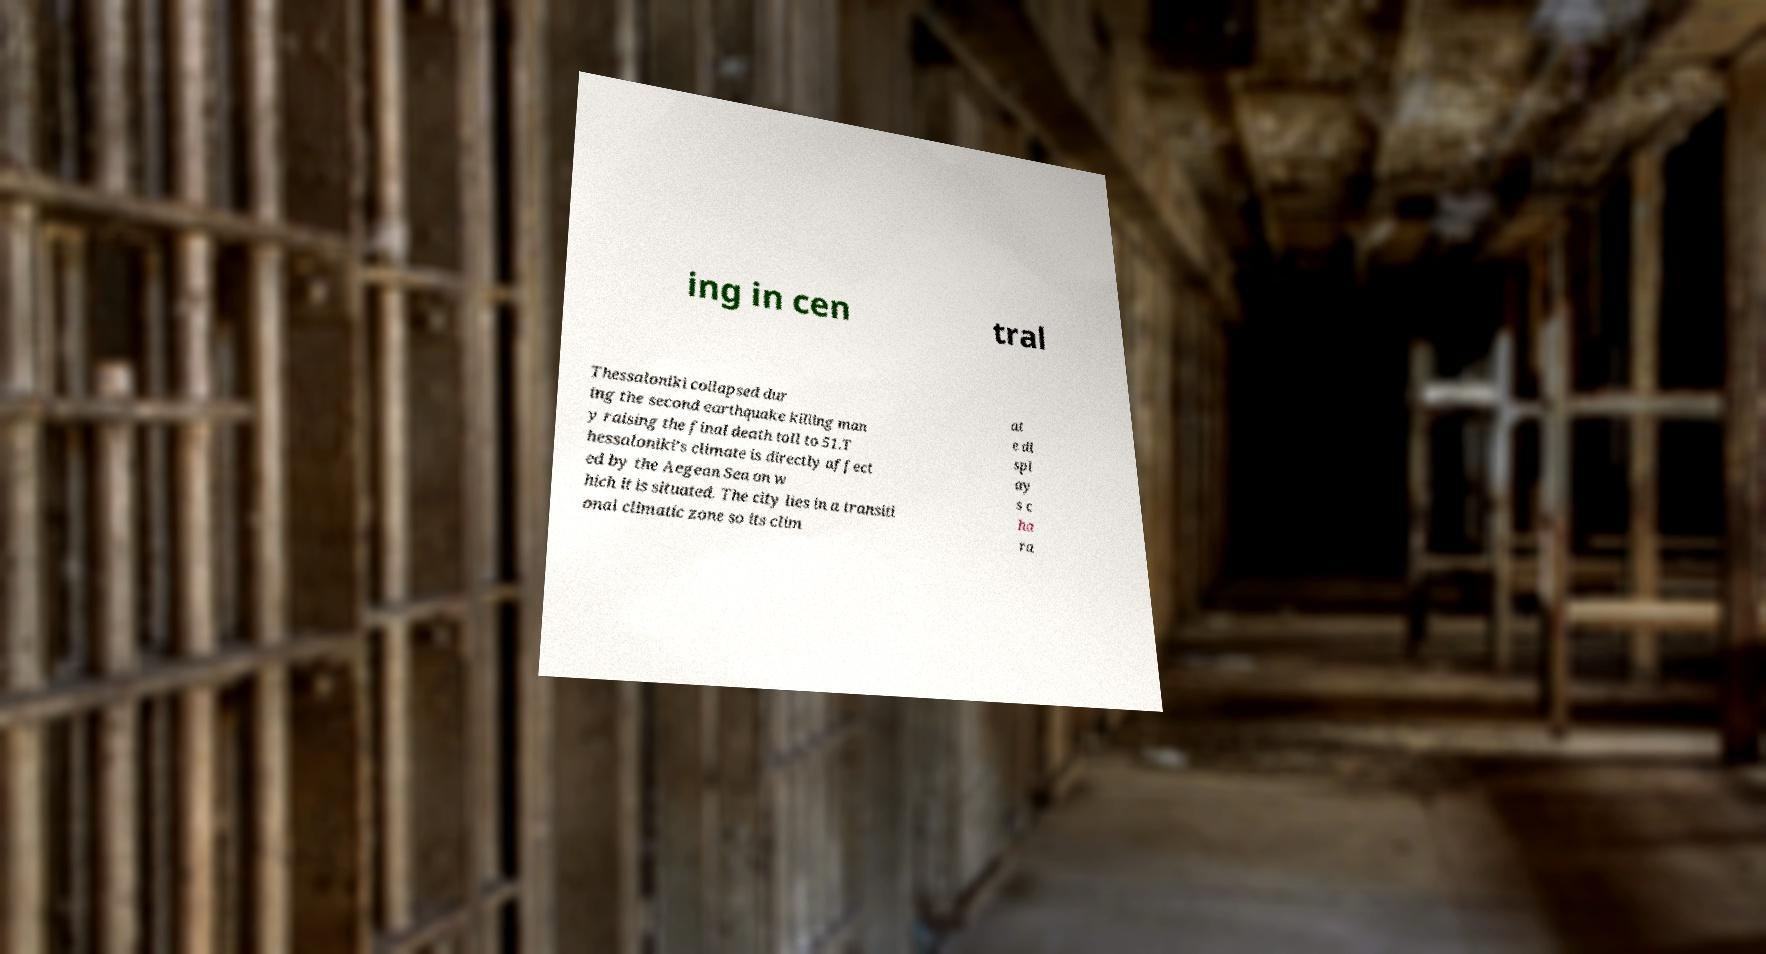Please read and relay the text visible in this image. What does it say? ing in cen tral Thessaloniki collapsed dur ing the second earthquake killing man y raising the final death toll to 51.T hessaloniki's climate is directly affect ed by the Aegean Sea on w hich it is situated. The city lies in a transiti onal climatic zone so its clim at e di spl ay s c ha ra 